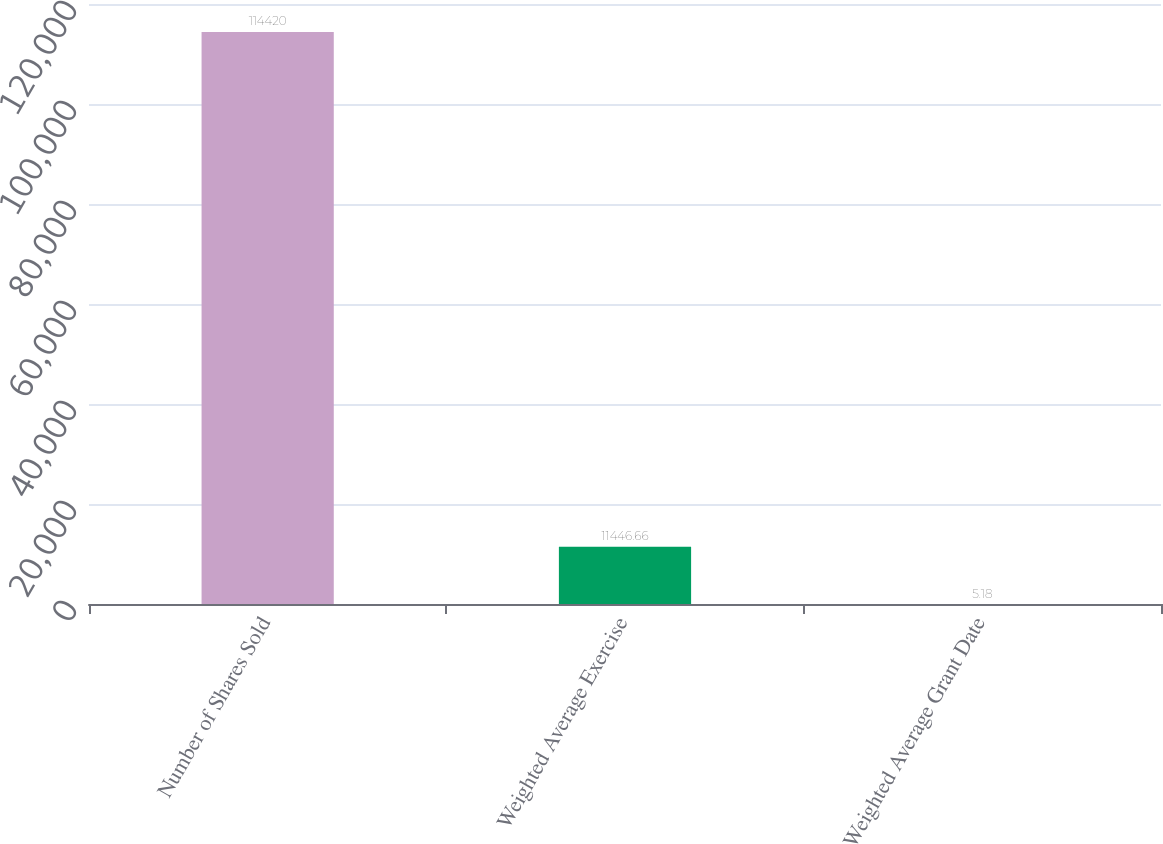Convert chart to OTSL. <chart><loc_0><loc_0><loc_500><loc_500><bar_chart><fcel>Number of Shares Sold<fcel>Weighted Average Exercise<fcel>Weighted Average Grant Date<nl><fcel>114420<fcel>11446.7<fcel>5.18<nl></chart> 